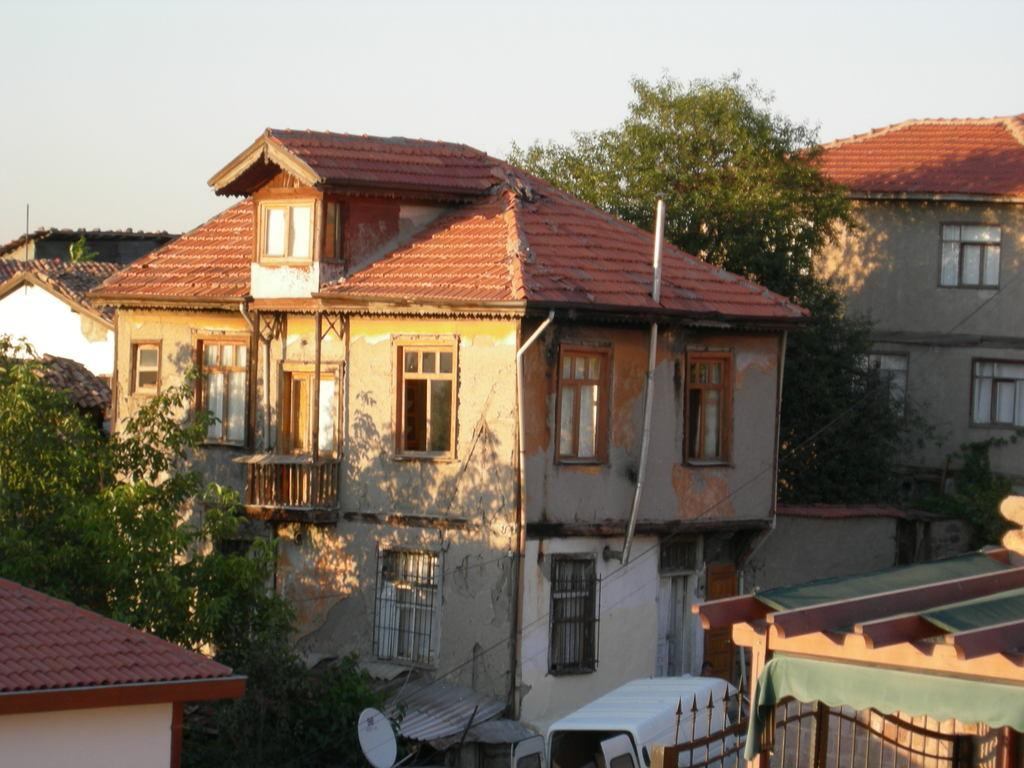What color are the roofs of the houses in the image? The roofs of the houses in the image are red. What type of vehicle can be seen in the image? There is a white color vehicle in the image. What type of vegetation is visible in the image? There are trees visible in the image. What is visible in the background of the image? The sky is visible in the background of the image. How many cattle are grazing in the image? There are no cattle present in the image. What credit card company is sponsoring the houses in the image? There is no credit card company mentioned or implied in the image. 